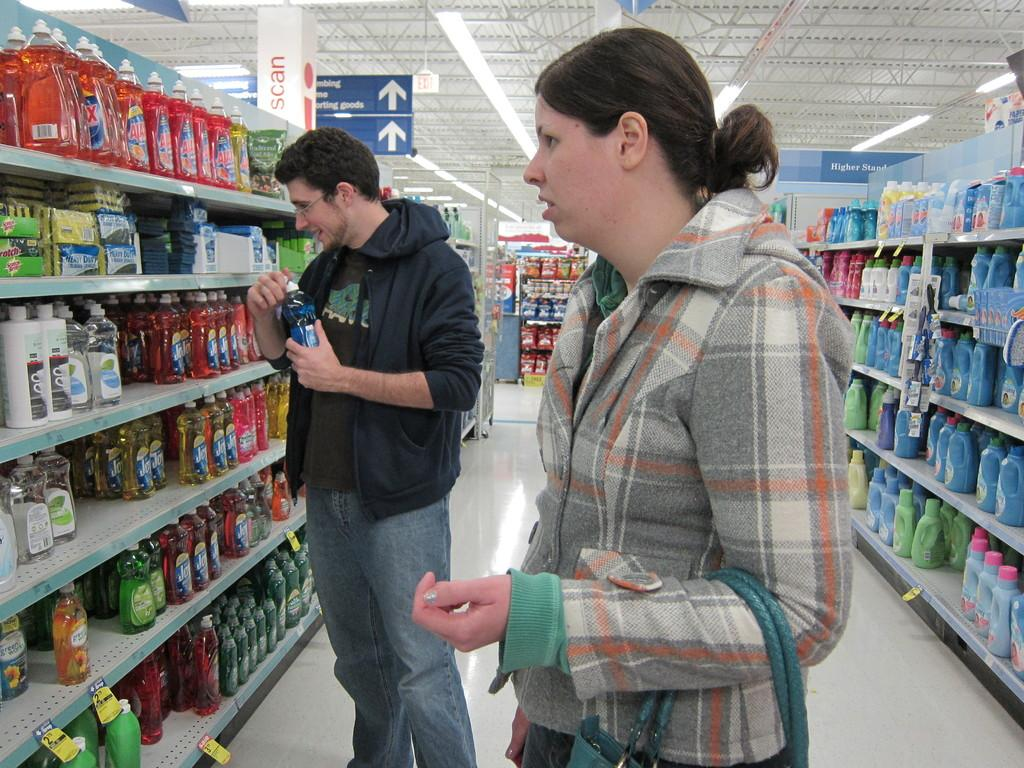<image>
Summarize the visual content of the image. Two people looking at cleaning products such as Ajax 